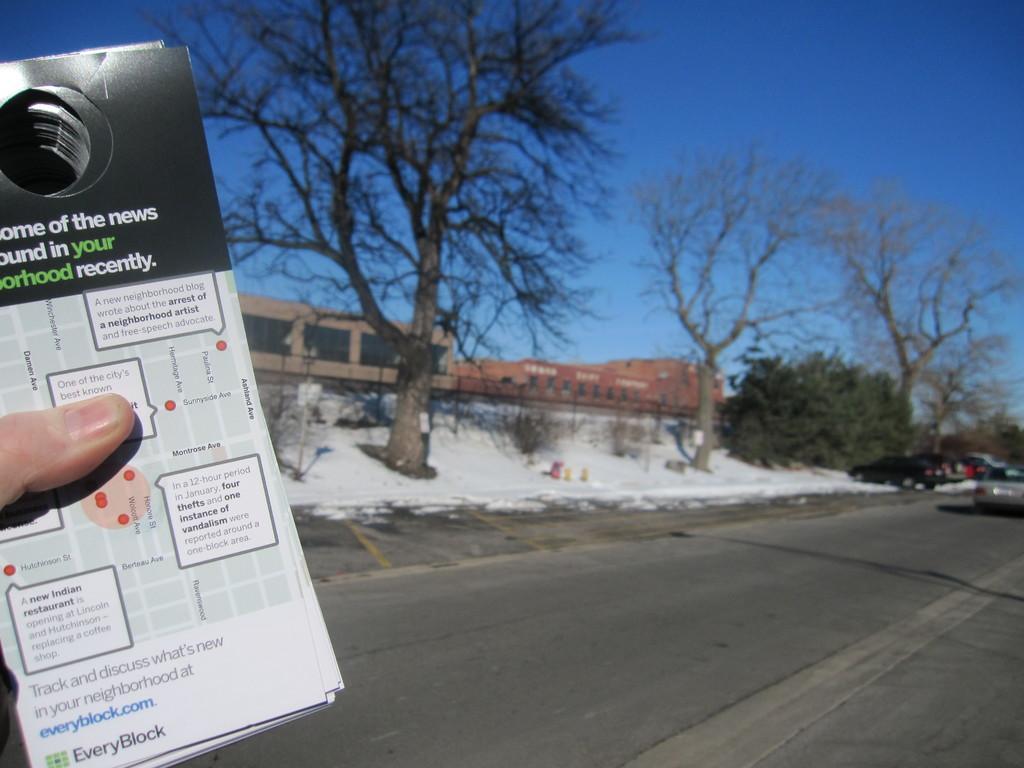In one or two sentences, can you explain what this image depicts? In this image I can see a finger of a person and I can see number of cards. On this card I can see something is written. In the background I can see a road, shadows, number of trees, few buildings, the sky and few vehicles. 